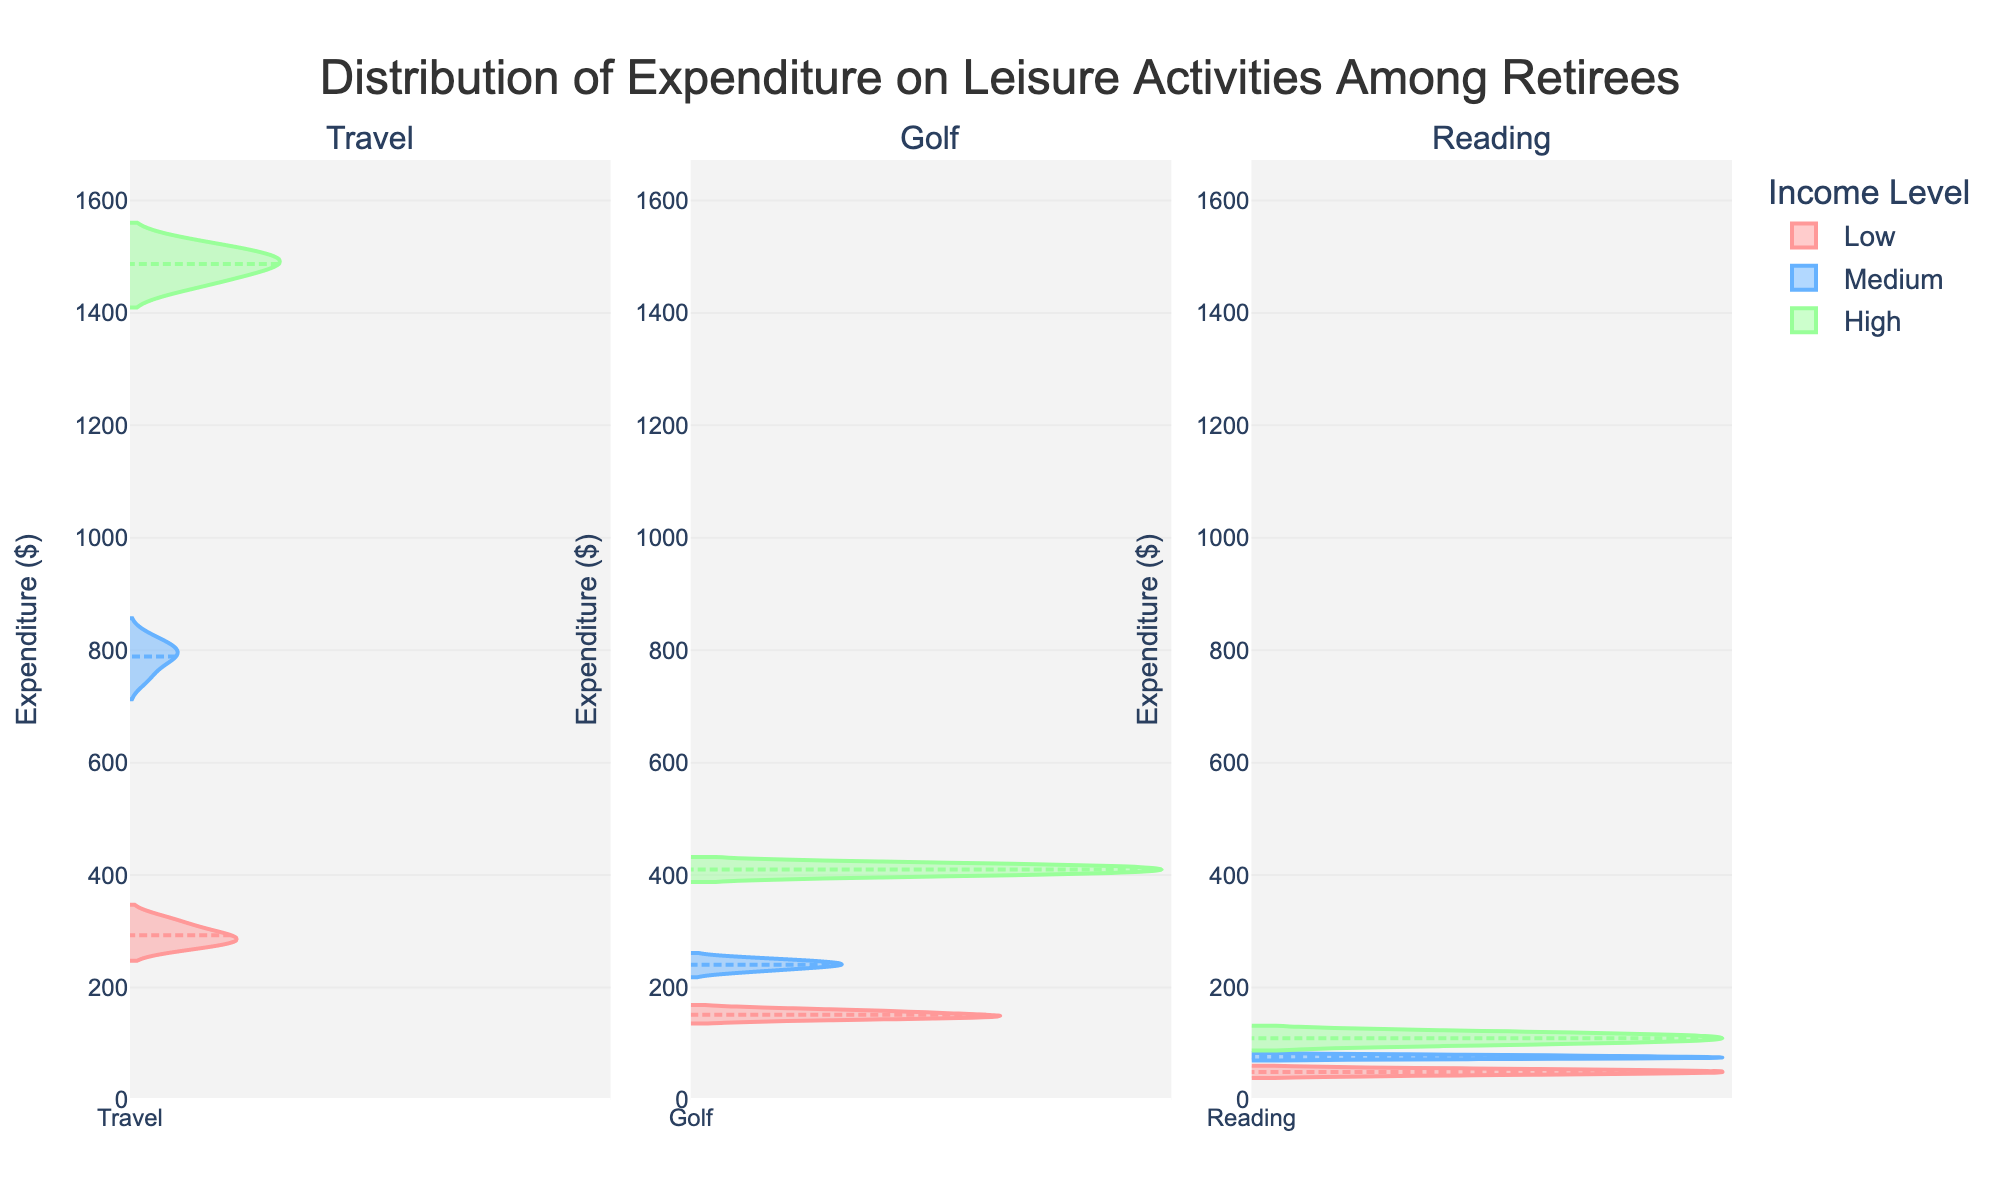what are the three leisure activities shown in the plot? The three leisure activities are shown as subplot titles in the figure. By observing the titles above each subplot, you can see the names of the activities.
Answer: Travel, Golf, Reading Which income level has the largest expenditure range for the activity "Travel"? To determine the largest expenditure range, look at the length of the violin plots for each income level in the "Travel" subplot. The "High" income level shows the widest range.
Answer: High What's the median expenditure for "Reading" by retirees with Medium income? One way to find the median expenditure in a violin chart is by looking at the meanline. In the "Reading" subplot for Medium income, identify where the meanline intersects the central mark.
Answer: $76 How does the average expenditure on "Golf" differ between retirees with Low and High incomes? To find the average expenditure, identify the mean lines in the "Golf" subplot for both Low and High incomes and compare them. The Low group has a mean of around $152, while the High group has around $410. The difference is $410 - $152.
Answer: $258 Which expenditure category shows the most significant difference between low-income and high-income retirees? By comparing the spreads and values of the violin plots across each activity, we can see that "Travel" shows the largest difference between Low and High income groups, with expenditures ranging approximately from $275 to $300 for Low and $1450 to $1520 for High.
Answer: Travel What's the highest expenditure in the "Golf" category? The topmost point of the violin plot for "Golf" shows the highest expenditure. In the High income category for "Golf", the highest expenditure is $420.
Answer: $420 How does the expenditure on "Reading" vary across different income levels? Observe the violin plots for "Reading" in each income category and compare their shapes and spread. The expenditure ranges are approximately $45 to $55 for Low, $74 to $80 for Medium, and $100 to $120 for High.
Answer: $45-$55, $74-$80, $100-$120 Is the median expenditure of "Travel" for medium-income higher than the max expenditure of "Golf" for low-income? By comparing the median line of "Travel" for Medium income which is around $795 to the highest point on "Golf" for Low income approximately $160, we can conclude that the median expenditure for "Travel" is indeed higher.
Answer: Yes 